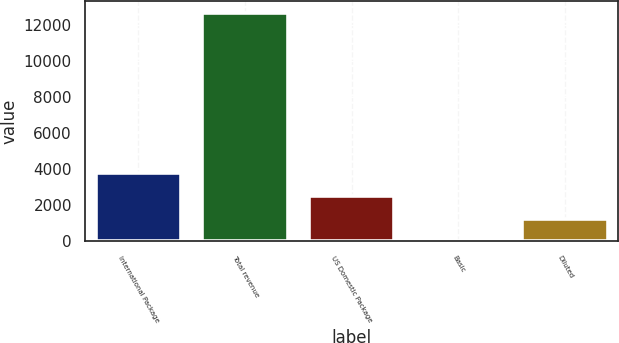Convert chart. <chart><loc_0><loc_0><loc_500><loc_500><bar_chart><fcel>International Package<fcel>Total revenue<fcel>US Domestic Package<fcel>Basic<fcel>Diluted<nl><fcel>3809.29<fcel>12697<fcel>2539.61<fcel>0.25<fcel>1269.93<nl></chart> 